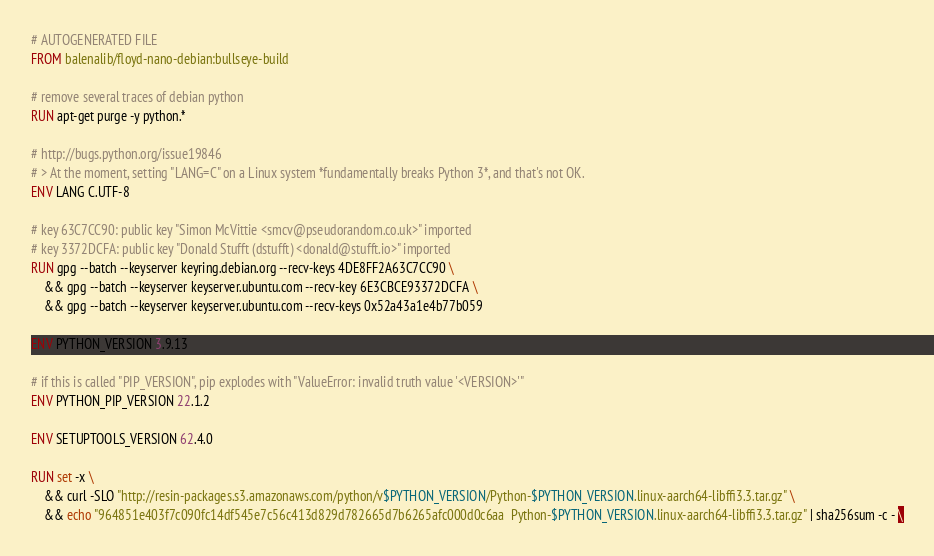Convert code to text. <code><loc_0><loc_0><loc_500><loc_500><_Dockerfile_># AUTOGENERATED FILE
FROM balenalib/floyd-nano-debian:bullseye-build

# remove several traces of debian python
RUN apt-get purge -y python.*

# http://bugs.python.org/issue19846
# > At the moment, setting "LANG=C" on a Linux system *fundamentally breaks Python 3*, and that's not OK.
ENV LANG C.UTF-8

# key 63C7CC90: public key "Simon McVittie <smcv@pseudorandom.co.uk>" imported
# key 3372DCFA: public key "Donald Stufft (dstufft) <donald@stufft.io>" imported
RUN gpg --batch --keyserver keyring.debian.org --recv-keys 4DE8FF2A63C7CC90 \
    && gpg --batch --keyserver keyserver.ubuntu.com --recv-key 6E3CBCE93372DCFA \
    && gpg --batch --keyserver keyserver.ubuntu.com --recv-keys 0x52a43a1e4b77b059

ENV PYTHON_VERSION 3.9.13

# if this is called "PIP_VERSION", pip explodes with "ValueError: invalid truth value '<VERSION>'"
ENV PYTHON_PIP_VERSION 22.1.2

ENV SETUPTOOLS_VERSION 62.4.0

RUN set -x \
    && curl -SLO "http://resin-packages.s3.amazonaws.com/python/v$PYTHON_VERSION/Python-$PYTHON_VERSION.linux-aarch64-libffi3.3.tar.gz" \
    && echo "964851e403f7c090fc14df545e7c56c413d829d782665d7b6265afc000d0c6aa  Python-$PYTHON_VERSION.linux-aarch64-libffi3.3.tar.gz" | sha256sum -c - \</code> 